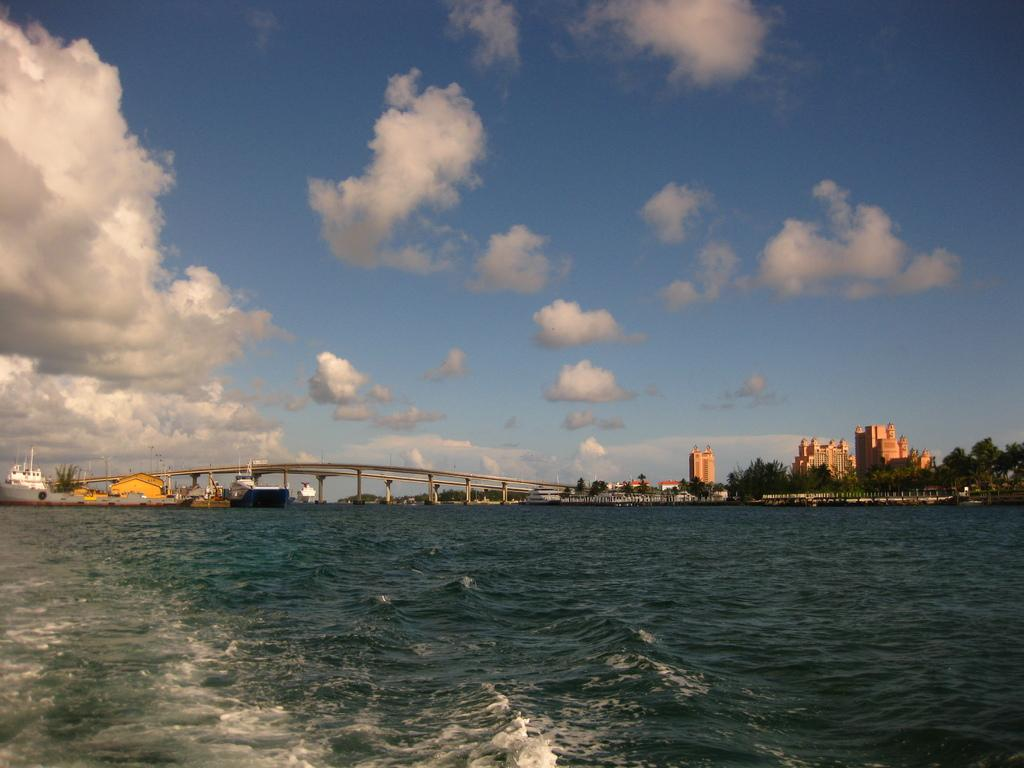What type of vehicles are in the image? There are boats in the image. Where are the boats located in relation to the water? The boats are above the water. What can be seen in the background of the image? There is a bridge, trees, buildings, and the sky visible in the background of the image. What is the condition of the sky in the image? The sky is visible in the background of the image, and clouds are present. What harmony is being played on the page in the image? There is no reference to a page or music in the image, so it is not possible to determine what harmony might be present. 